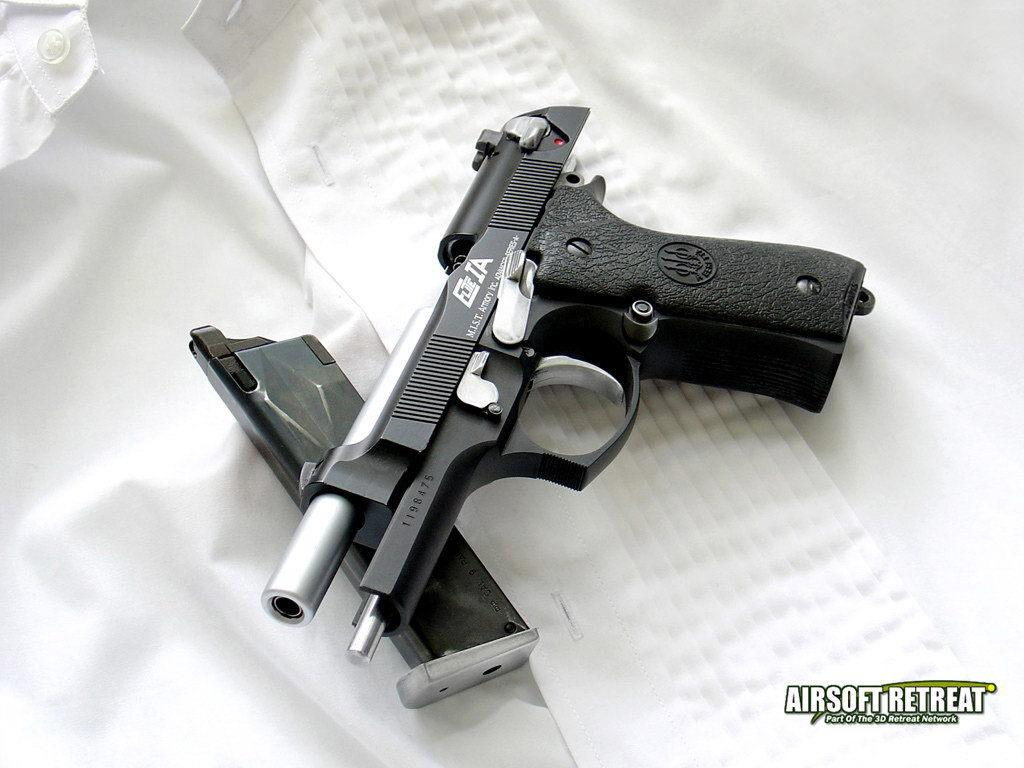What object is the main focus of the image? There is a gun in the image. What is the color of the surface the gun is placed on? The gun is on a white surface. Is there any additional mark or feature in the image? Yes, there is a watermark in the right corner of the image. What type of land can be seen in the background of the image? There is no land visible in the image, as it only features a gun on a white surface and a watermark in the corner. What color paint is used to create the watermark in the image? The watermark is a digital feature and does not involve paint, so it cannot be described in terms of paint color. 